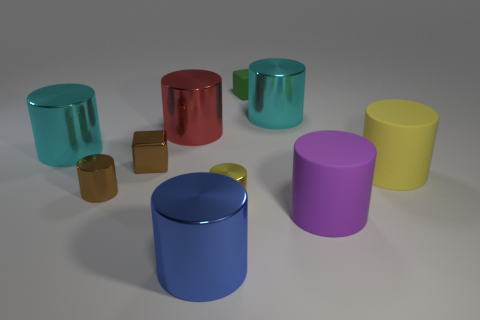Subtract all cyan cylinders. How many cylinders are left? 6 Subtract all big purple cylinders. How many cylinders are left? 7 Subtract all brown cylinders. Subtract all purple spheres. How many cylinders are left? 7 Subtract all blocks. How many objects are left? 8 Subtract 0 purple spheres. How many objects are left? 10 Subtract all tiny brown things. Subtract all small green rubber blocks. How many objects are left? 7 Add 9 large red shiny cylinders. How many large red shiny cylinders are left? 10 Add 7 big rubber cylinders. How many big rubber cylinders exist? 9 